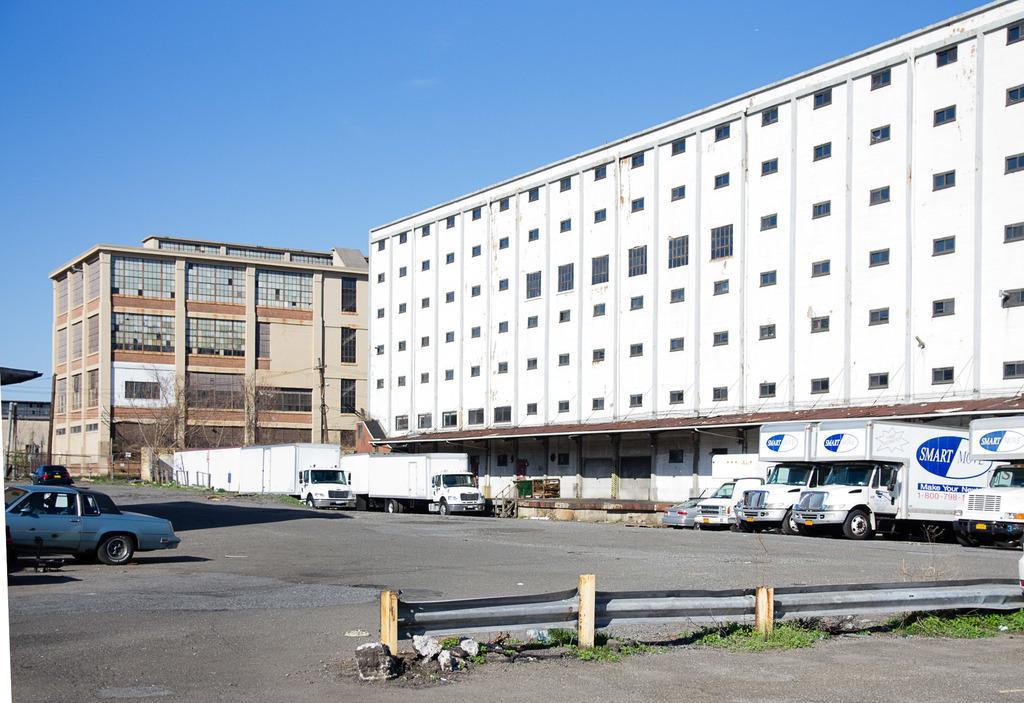Can you describe this image briefly? In this image I can see few vehicles and the fencing. In the background I can see few buildings in white and cream color, few dried trees and the sky is in blue color. 